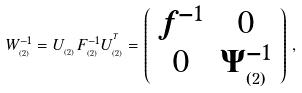Convert formula to latex. <formula><loc_0><loc_0><loc_500><loc_500>W _ { _ { ( 2 ) } } ^ { - 1 } = U _ { _ { ( 2 ) } } F _ { _ { ( 2 ) } } ^ { - 1 } U _ { _ { ( 2 ) } } ^ { ^ { T } } = \left ( \begin{array} { c c } f ^ { - 1 } & 0 \\ 0 & \Psi _ { _ { ( 2 ) } } ^ { - 1 } \end{array} \right ) \, ,</formula> 